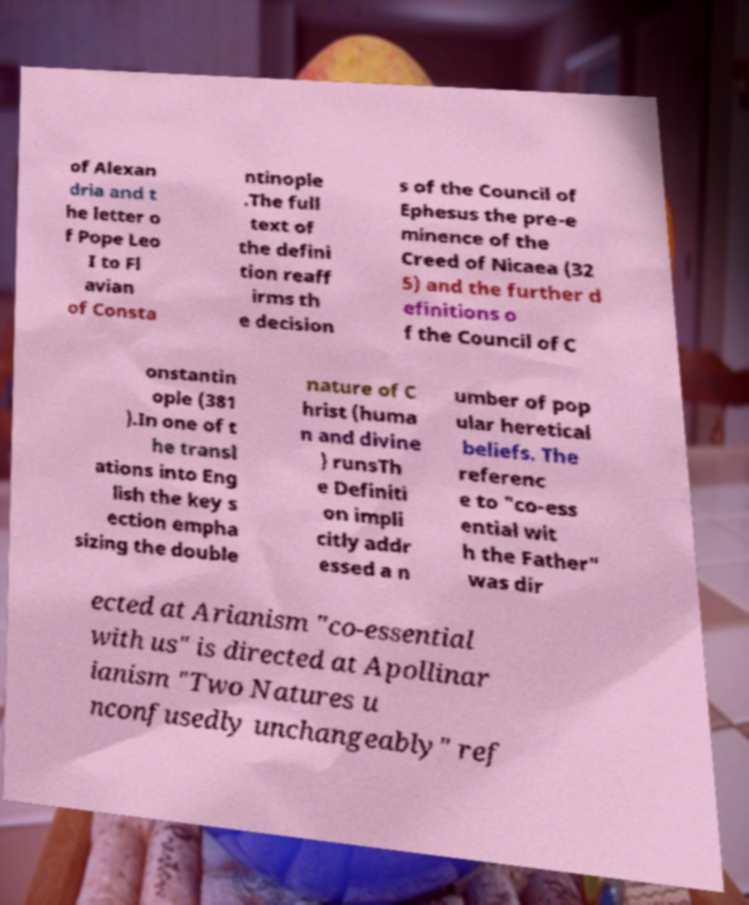Could you assist in decoding the text presented in this image and type it out clearly? of Alexan dria and t he letter o f Pope Leo I to Fl avian of Consta ntinople .The full text of the defini tion reaff irms th e decision s of the Council of Ephesus the pre-e minence of the Creed of Nicaea (32 5) and the further d efinitions o f the Council of C onstantin ople (381 ).In one of t he transl ations into Eng lish the key s ection empha sizing the double nature of C hrist (huma n and divine ) runsTh e Definiti on impli citly addr essed a n umber of pop ular heretical beliefs. The referenc e to "co-ess ential wit h the Father" was dir ected at Arianism "co-essential with us" is directed at Apollinar ianism "Two Natures u nconfusedly unchangeably" ref 